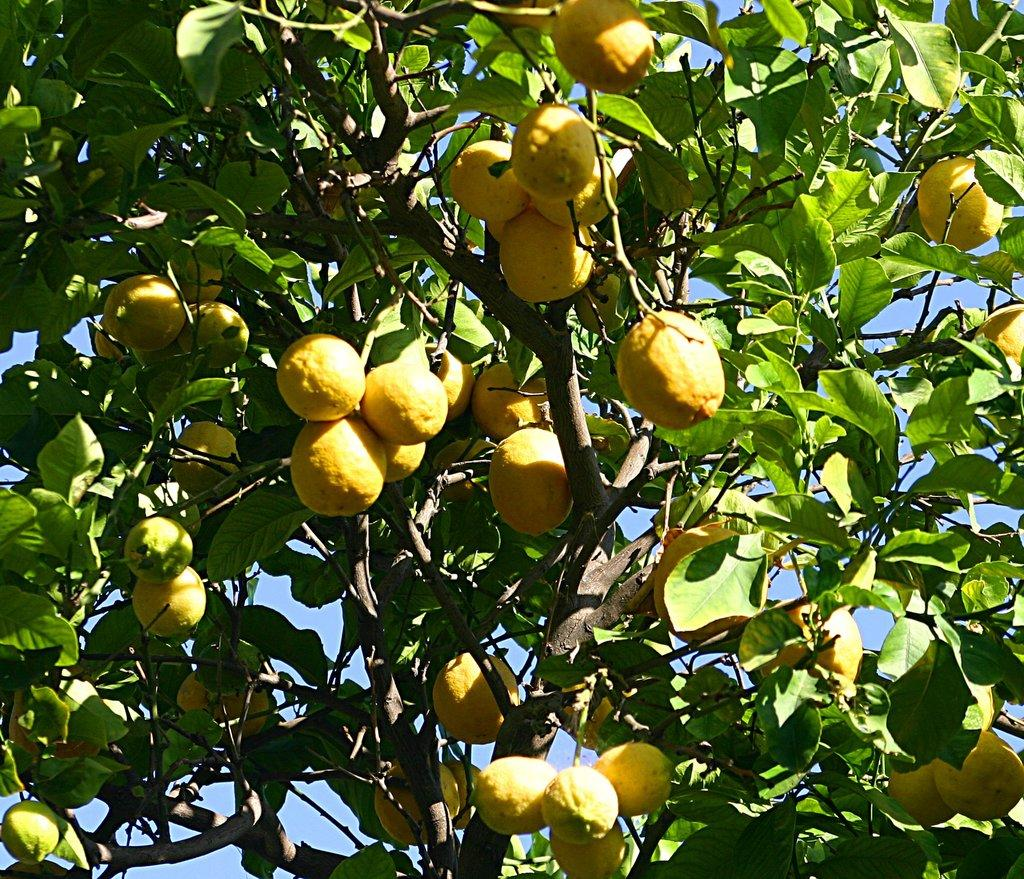What type of tree is present in the image? There is a lemon tree in the image. What can be inferred about the climate or location from the presence of this tree? The presence of a lemon tree suggests a warm climate, as lemons typically grow in warmer regions. What might be the purpose of this tree? The lemon tree may be grown for its fruit, which can be used for culinary or other purposes. What historical event is depicted in the image involving a zinc pull? There is no historical event or zinc pull present in the image; it only features a lemon tree. 